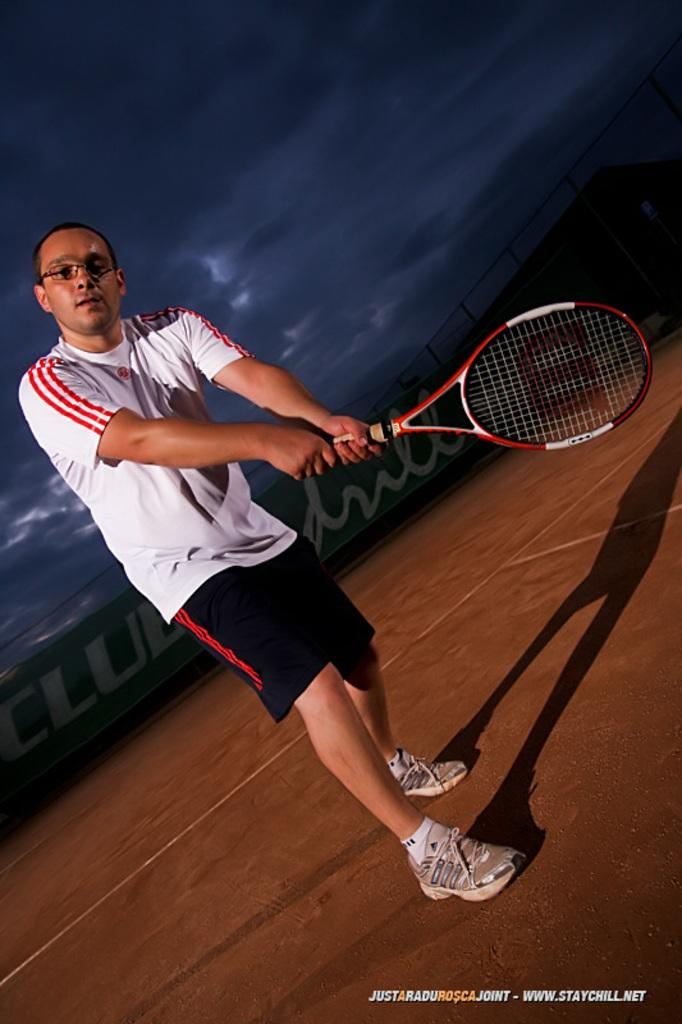What is the main subject of the image? There is a man in the image. What is the man doing in the image? The man is standing and holding a racket. What can be seen in the background of the image? The sky is visible in the background of the image. How would you describe the weather based on the sky in the image? The sky appears to be cloudy. What type of shoes is the man wearing in the image? There is no information about the man's shoes in the image, so we cannot determine what type of shoes he is wearing. What is the man trying to smash in the image? There is no indication of the man attempting to smash anything in the image; he is simply holding a racket. 